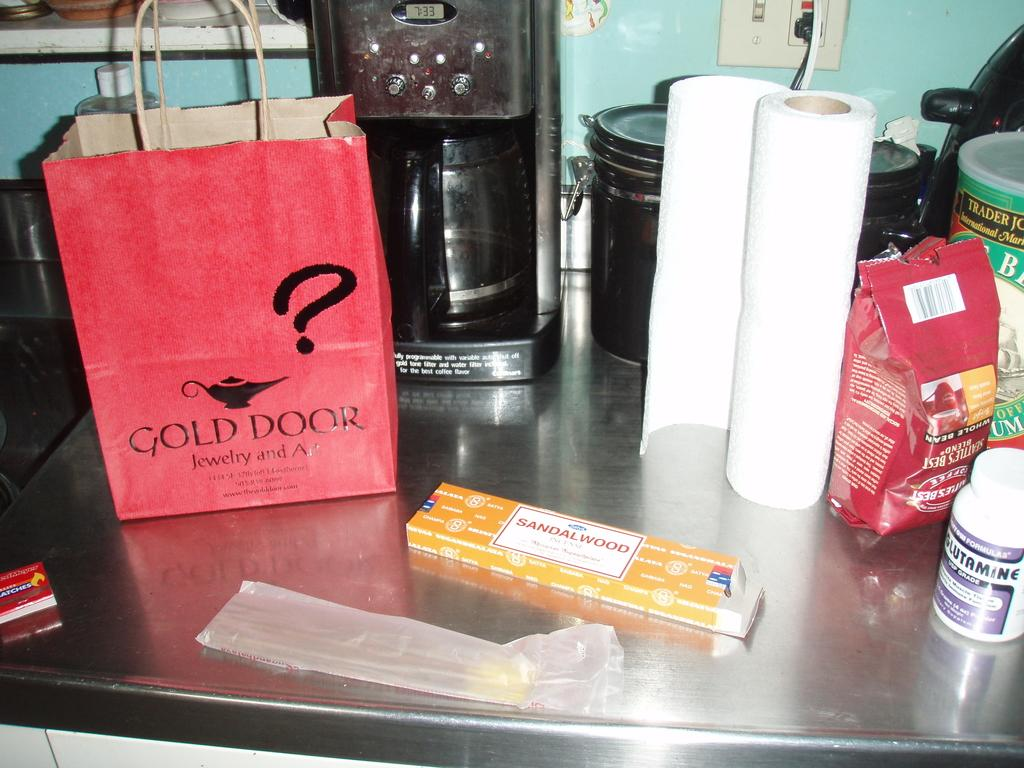Provide a one-sentence caption for the provided image. A paper bag from the Gold Door jewelry shop sits on a table next to some sandalwood incense sticks. 